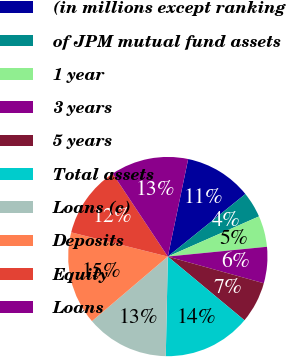Convert chart to OTSL. <chart><loc_0><loc_0><loc_500><loc_500><pie_chart><fcel>(in millions except ranking<fcel>of JPM mutual fund assets<fcel>1 year<fcel>3 years<fcel>5 years<fcel>Total assets<fcel>Loans (c)<fcel>Deposits<fcel>Equity<fcel>Loans<nl><fcel>10.92%<fcel>4.2%<fcel>5.04%<fcel>5.88%<fcel>6.72%<fcel>14.29%<fcel>13.45%<fcel>15.13%<fcel>11.76%<fcel>12.61%<nl></chart> 